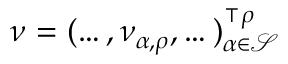<formula> <loc_0><loc_0><loc_500><loc_500>\nu = ( \dots , \nu _ { \alpha , \rho } , \dots ) _ { \alpha \in \mathcal { S } } ^ { \intercal \rho }</formula> 